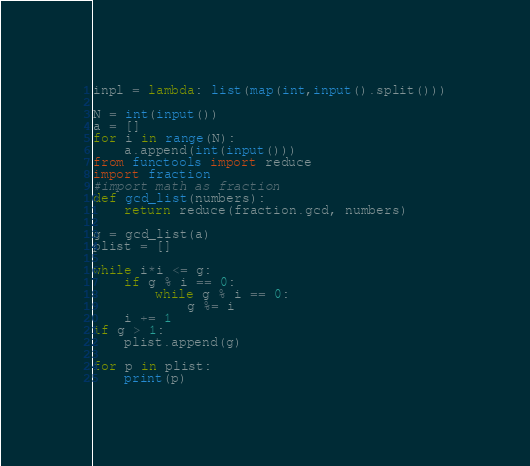<code> <loc_0><loc_0><loc_500><loc_500><_Python_>inpl = lambda: list(map(int,input().split()))

N = int(input())
a = []
for i in range(N):
    a.append(int(input()))
from functools import reduce
import fraction
#import math as fraction
def gcd_list(numbers):
    return reduce(fraction.gcd, numbers)

g = gcd_list(a)
plist = []

while i*i <= g:
    if g % i == 0:
        while g % i == 0:
            g %= i
    i += 1
if g > 1:
    plist.append(g)

for p in plist:
    print(p)</code> 